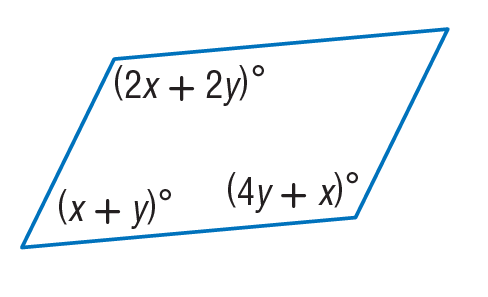Answer the mathemtical geometry problem and directly provide the correct option letter.
Question: Find x so that the quadrilateral is a parallelogram.
Choices: A: 30 B: 40 C: 70 D: 85 B 